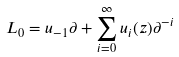Convert formula to latex. <formula><loc_0><loc_0><loc_500><loc_500>L _ { 0 } = u _ { - 1 } \partial + \sum _ { i = 0 } ^ { \infty } u _ { i } ( z ) \partial ^ { - i }</formula> 